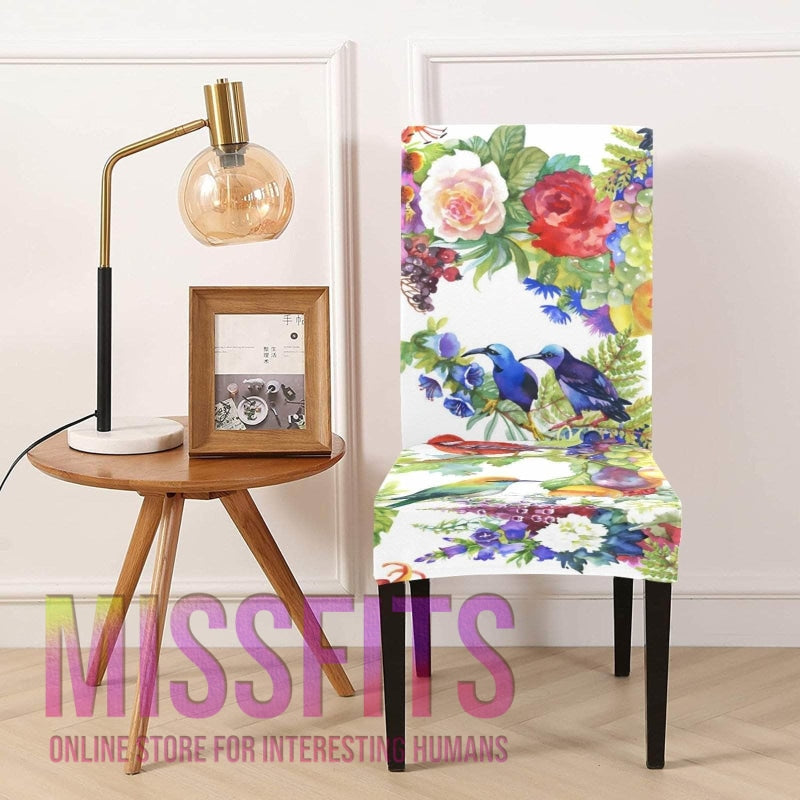How many chairs would there be in the image if someone deleted zero chair from the picture? 1 